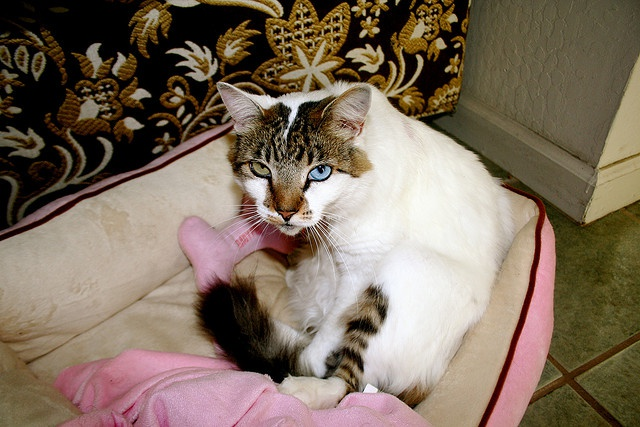Describe the objects in this image and their specific colors. I can see bed in black, darkgray, lightpink, tan, and brown tones, cat in black, lightgray, and darkgray tones, couch in black, olive, maroon, and darkgray tones, and couch in black, tan, lightpink, and gray tones in this image. 